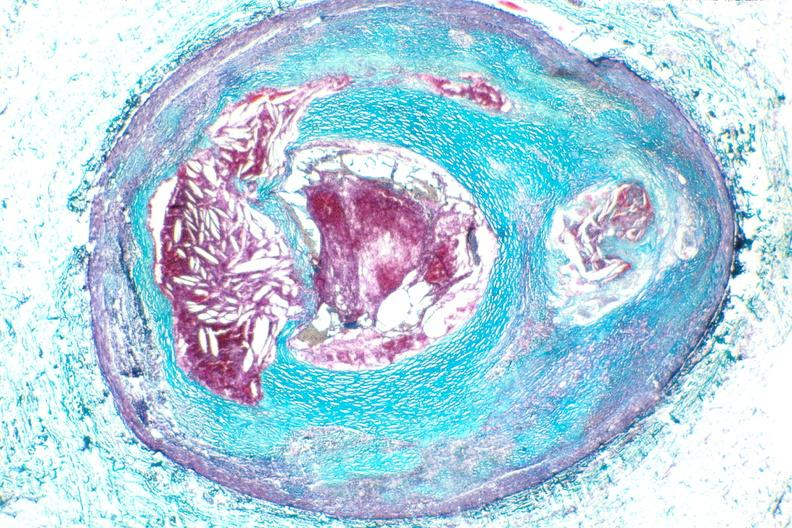does siamese twins show right coronary artery, atherosclerosis and acute thrombus?
Answer the question using a single word or phrase. No 